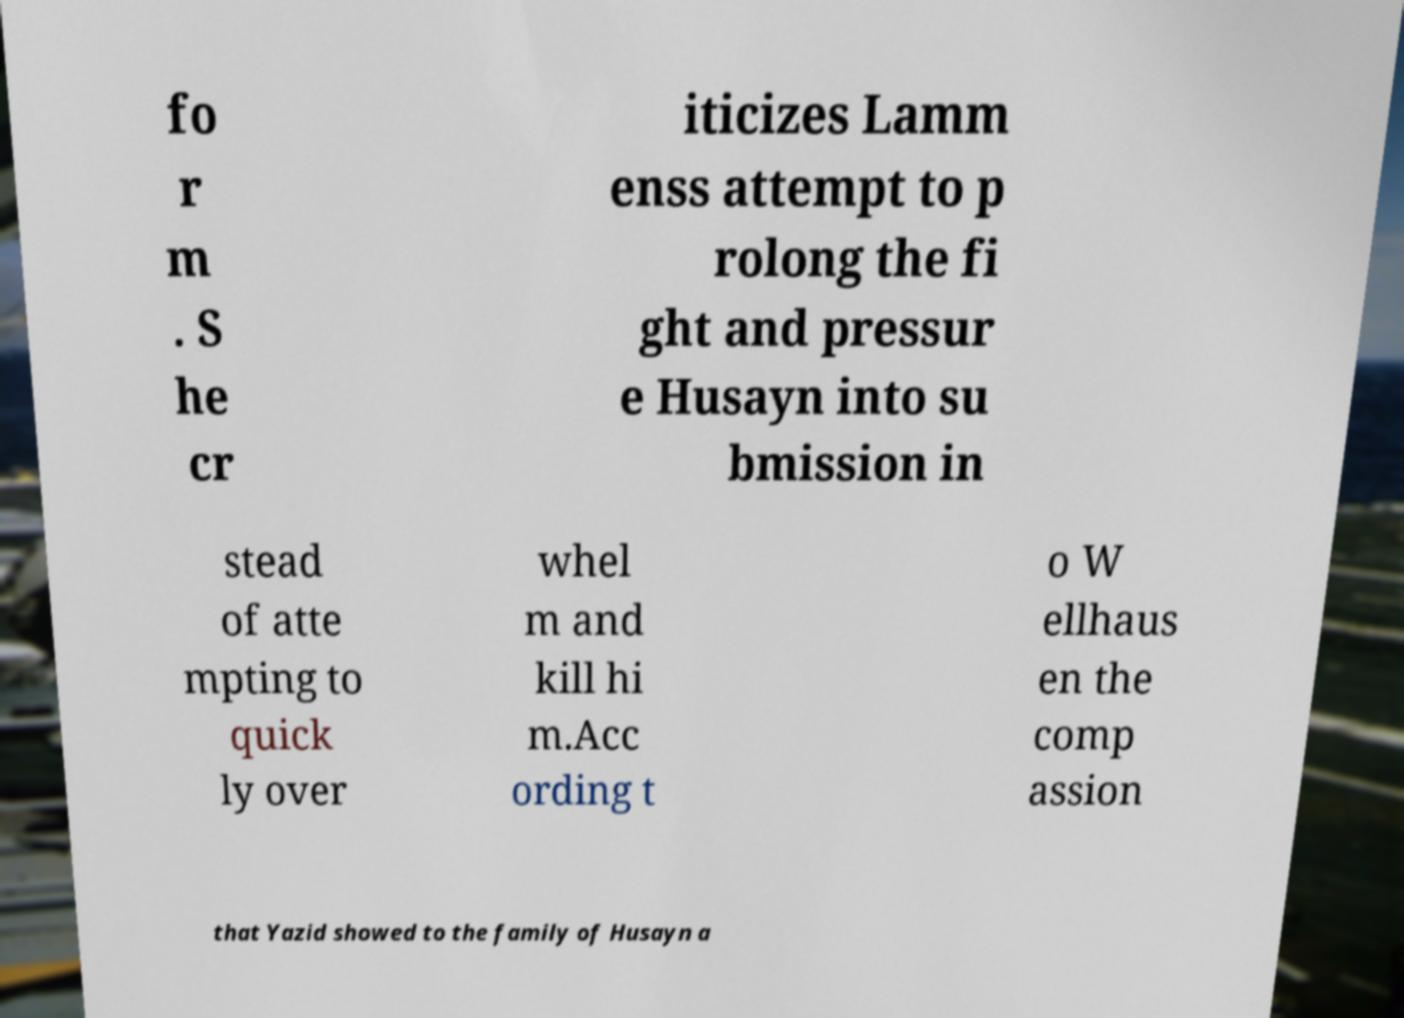Please read and relay the text visible in this image. What does it say? fo r m . S he cr iticizes Lamm enss attempt to p rolong the fi ght and pressur e Husayn into su bmission in stead of atte mpting to quick ly over whel m and kill hi m.Acc ording t o W ellhaus en the comp assion that Yazid showed to the family of Husayn a 